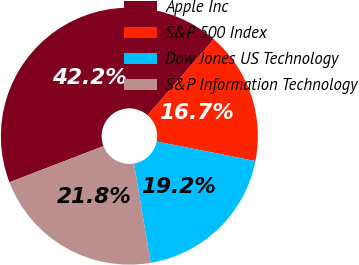Convert chart. <chart><loc_0><loc_0><loc_500><loc_500><pie_chart><fcel>Apple Inc<fcel>S&P 500 Index<fcel>Dow Jones US Technology<fcel>S&P Information Technology<nl><fcel>42.25%<fcel>16.69%<fcel>19.25%<fcel>21.81%<nl></chart> 